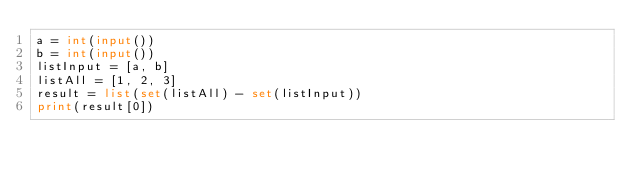<code> <loc_0><loc_0><loc_500><loc_500><_Python_>a = int(input())
b = int(input())
listInput = [a, b]
listAll = [1, 2, 3]
result = list(set(listAll) - set(listInput))
print(result[0])</code> 